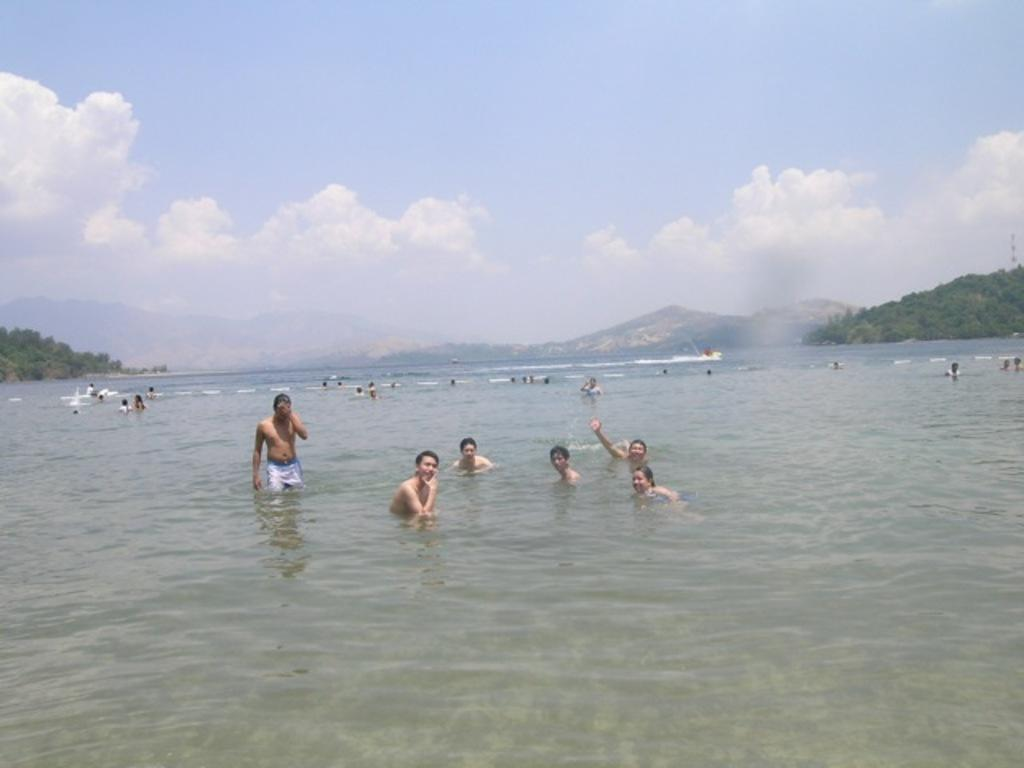What are the people in the image doing? There are people playing in the water in the image. What can be seen around the water? There are trees visible around the water. What is visible in the background of the image? There are hills visible in the background. What type of screw can be seen holding the boundary in place in the image? There is no screw or boundary present in the image; it features people playing in the water with trees and hills visible in the background. 